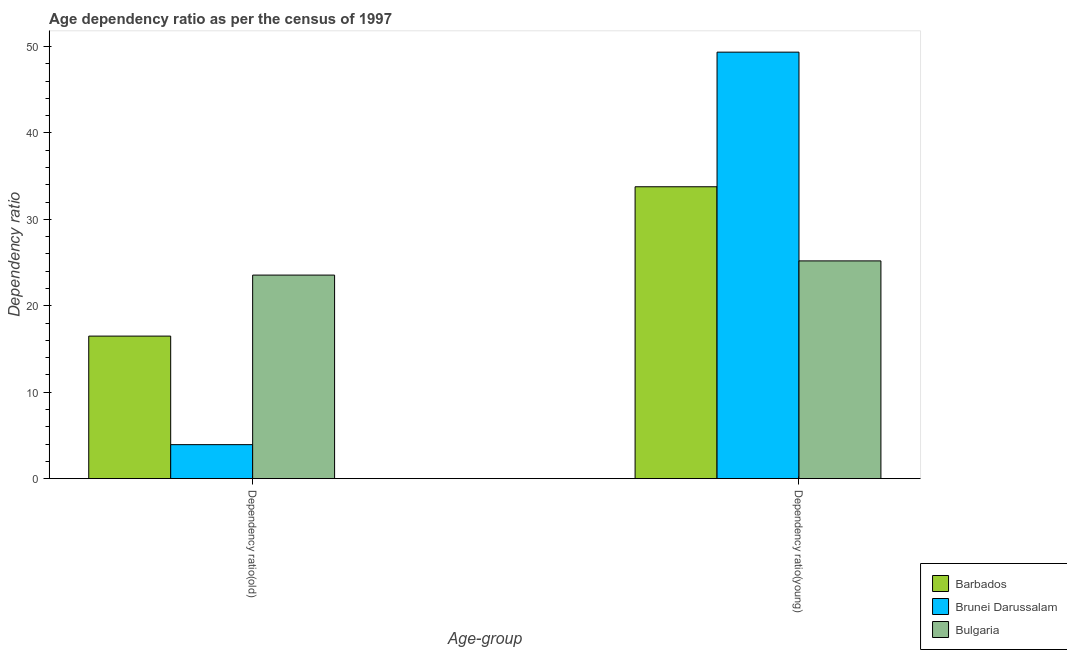How many different coloured bars are there?
Your response must be concise. 3. How many groups of bars are there?
Provide a short and direct response. 2. Are the number of bars on each tick of the X-axis equal?
Offer a terse response. Yes. What is the label of the 1st group of bars from the left?
Your response must be concise. Dependency ratio(old). What is the age dependency ratio(old) in Bulgaria?
Provide a short and direct response. 23.55. Across all countries, what is the maximum age dependency ratio(old)?
Give a very brief answer. 23.55. Across all countries, what is the minimum age dependency ratio(old)?
Keep it short and to the point. 3.93. In which country was the age dependency ratio(young) minimum?
Your response must be concise. Bulgaria. What is the total age dependency ratio(young) in the graph?
Ensure brevity in your answer.  108.31. What is the difference between the age dependency ratio(old) in Bulgaria and that in Brunei Darussalam?
Give a very brief answer. 19.62. What is the difference between the age dependency ratio(young) in Brunei Darussalam and the age dependency ratio(old) in Barbados?
Give a very brief answer. 32.85. What is the average age dependency ratio(old) per country?
Offer a terse response. 14.66. What is the difference between the age dependency ratio(old) and age dependency ratio(young) in Brunei Darussalam?
Ensure brevity in your answer.  -45.42. What is the ratio of the age dependency ratio(old) in Barbados to that in Bulgaria?
Provide a short and direct response. 0.7. What does the 1st bar from the left in Dependency ratio(young) represents?
Ensure brevity in your answer.  Barbados. What does the 2nd bar from the right in Dependency ratio(old) represents?
Make the answer very short. Brunei Darussalam. How many bars are there?
Offer a very short reply. 6. Are all the bars in the graph horizontal?
Make the answer very short. No. What is the difference between two consecutive major ticks on the Y-axis?
Offer a very short reply. 10. Does the graph contain any zero values?
Ensure brevity in your answer.  No. Does the graph contain grids?
Ensure brevity in your answer.  No. What is the title of the graph?
Provide a short and direct response. Age dependency ratio as per the census of 1997. What is the label or title of the X-axis?
Your answer should be compact. Age-group. What is the label or title of the Y-axis?
Make the answer very short. Dependency ratio. What is the Dependency ratio in Barbados in Dependency ratio(old)?
Provide a short and direct response. 16.49. What is the Dependency ratio of Brunei Darussalam in Dependency ratio(old)?
Provide a succinct answer. 3.93. What is the Dependency ratio in Bulgaria in Dependency ratio(old)?
Ensure brevity in your answer.  23.55. What is the Dependency ratio in Barbados in Dependency ratio(young)?
Ensure brevity in your answer.  33.77. What is the Dependency ratio of Brunei Darussalam in Dependency ratio(young)?
Your answer should be compact. 49.35. What is the Dependency ratio of Bulgaria in Dependency ratio(young)?
Offer a very short reply. 25.19. Across all Age-group, what is the maximum Dependency ratio of Barbados?
Your answer should be compact. 33.77. Across all Age-group, what is the maximum Dependency ratio of Brunei Darussalam?
Provide a short and direct response. 49.35. Across all Age-group, what is the maximum Dependency ratio in Bulgaria?
Keep it short and to the point. 25.19. Across all Age-group, what is the minimum Dependency ratio in Barbados?
Ensure brevity in your answer.  16.49. Across all Age-group, what is the minimum Dependency ratio of Brunei Darussalam?
Keep it short and to the point. 3.93. Across all Age-group, what is the minimum Dependency ratio in Bulgaria?
Keep it short and to the point. 23.55. What is the total Dependency ratio of Barbados in the graph?
Provide a short and direct response. 50.26. What is the total Dependency ratio in Brunei Darussalam in the graph?
Ensure brevity in your answer.  53.28. What is the total Dependency ratio in Bulgaria in the graph?
Offer a very short reply. 48.74. What is the difference between the Dependency ratio of Barbados in Dependency ratio(old) and that in Dependency ratio(young)?
Provide a succinct answer. -17.28. What is the difference between the Dependency ratio in Brunei Darussalam in Dependency ratio(old) and that in Dependency ratio(young)?
Your answer should be very brief. -45.41. What is the difference between the Dependency ratio in Bulgaria in Dependency ratio(old) and that in Dependency ratio(young)?
Ensure brevity in your answer.  -1.64. What is the difference between the Dependency ratio of Barbados in Dependency ratio(old) and the Dependency ratio of Brunei Darussalam in Dependency ratio(young)?
Your answer should be very brief. -32.85. What is the difference between the Dependency ratio of Barbados in Dependency ratio(old) and the Dependency ratio of Bulgaria in Dependency ratio(young)?
Make the answer very short. -8.7. What is the difference between the Dependency ratio in Brunei Darussalam in Dependency ratio(old) and the Dependency ratio in Bulgaria in Dependency ratio(young)?
Ensure brevity in your answer.  -21.26. What is the average Dependency ratio in Barbados per Age-group?
Keep it short and to the point. 25.13. What is the average Dependency ratio of Brunei Darussalam per Age-group?
Provide a succinct answer. 26.64. What is the average Dependency ratio of Bulgaria per Age-group?
Provide a short and direct response. 24.37. What is the difference between the Dependency ratio of Barbados and Dependency ratio of Brunei Darussalam in Dependency ratio(old)?
Keep it short and to the point. 12.56. What is the difference between the Dependency ratio of Barbados and Dependency ratio of Bulgaria in Dependency ratio(old)?
Offer a very short reply. -7.06. What is the difference between the Dependency ratio in Brunei Darussalam and Dependency ratio in Bulgaria in Dependency ratio(old)?
Ensure brevity in your answer.  -19.62. What is the difference between the Dependency ratio of Barbados and Dependency ratio of Brunei Darussalam in Dependency ratio(young)?
Your answer should be compact. -15.58. What is the difference between the Dependency ratio of Barbados and Dependency ratio of Bulgaria in Dependency ratio(young)?
Provide a short and direct response. 8.58. What is the difference between the Dependency ratio of Brunei Darussalam and Dependency ratio of Bulgaria in Dependency ratio(young)?
Give a very brief answer. 24.15. What is the ratio of the Dependency ratio in Barbados in Dependency ratio(old) to that in Dependency ratio(young)?
Give a very brief answer. 0.49. What is the ratio of the Dependency ratio in Brunei Darussalam in Dependency ratio(old) to that in Dependency ratio(young)?
Give a very brief answer. 0.08. What is the ratio of the Dependency ratio of Bulgaria in Dependency ratio(old) to that in Dependency ratio(young)?
Provide a short and direct response. 0.93. What is the difference between the highest and the second highest Dependency ratio of Barbados?
Your response must be concise. 17.28. What is the difference between the highest and the second highest Dependency ratio in Brunei Darussalam?
Keep it short and to the point. 45.41. What is the difference between the highest and the second highest Dependency ratio of Bulgaria?
Offer a terse response. 1.64. What is the difference between the highest and the lowest Dependency ratio in Barbados?
Offer a terse response. 17.28. What is the difference between the highest and the lowest Dependency ratio in Brunei Darussalam?
Your answer should be compact. 45.41. What is the difference between the highest and the lowest Dependency ratio of Bulgaria?
Provide a succinct answer. 1.64. 